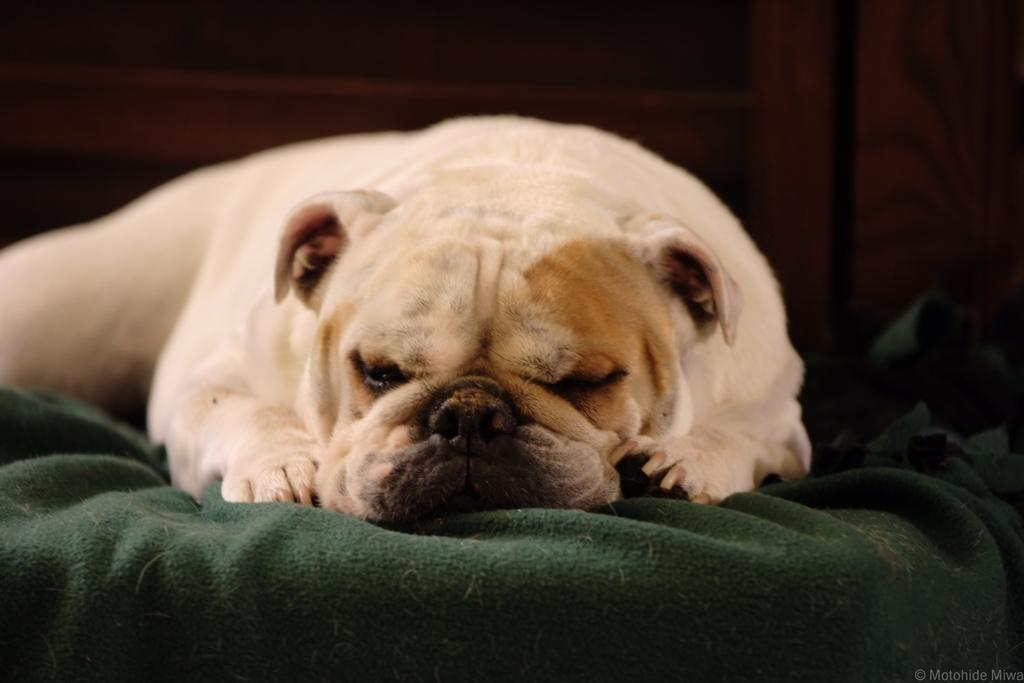What animal is present in the image? There is a dog in the image. What is the dog lying on? The dog is lying on a green colored cloth. What type of soap is the dog using to clean itself in the image? There is no soap present in the image, and the dog is not shown cleaning itself. 